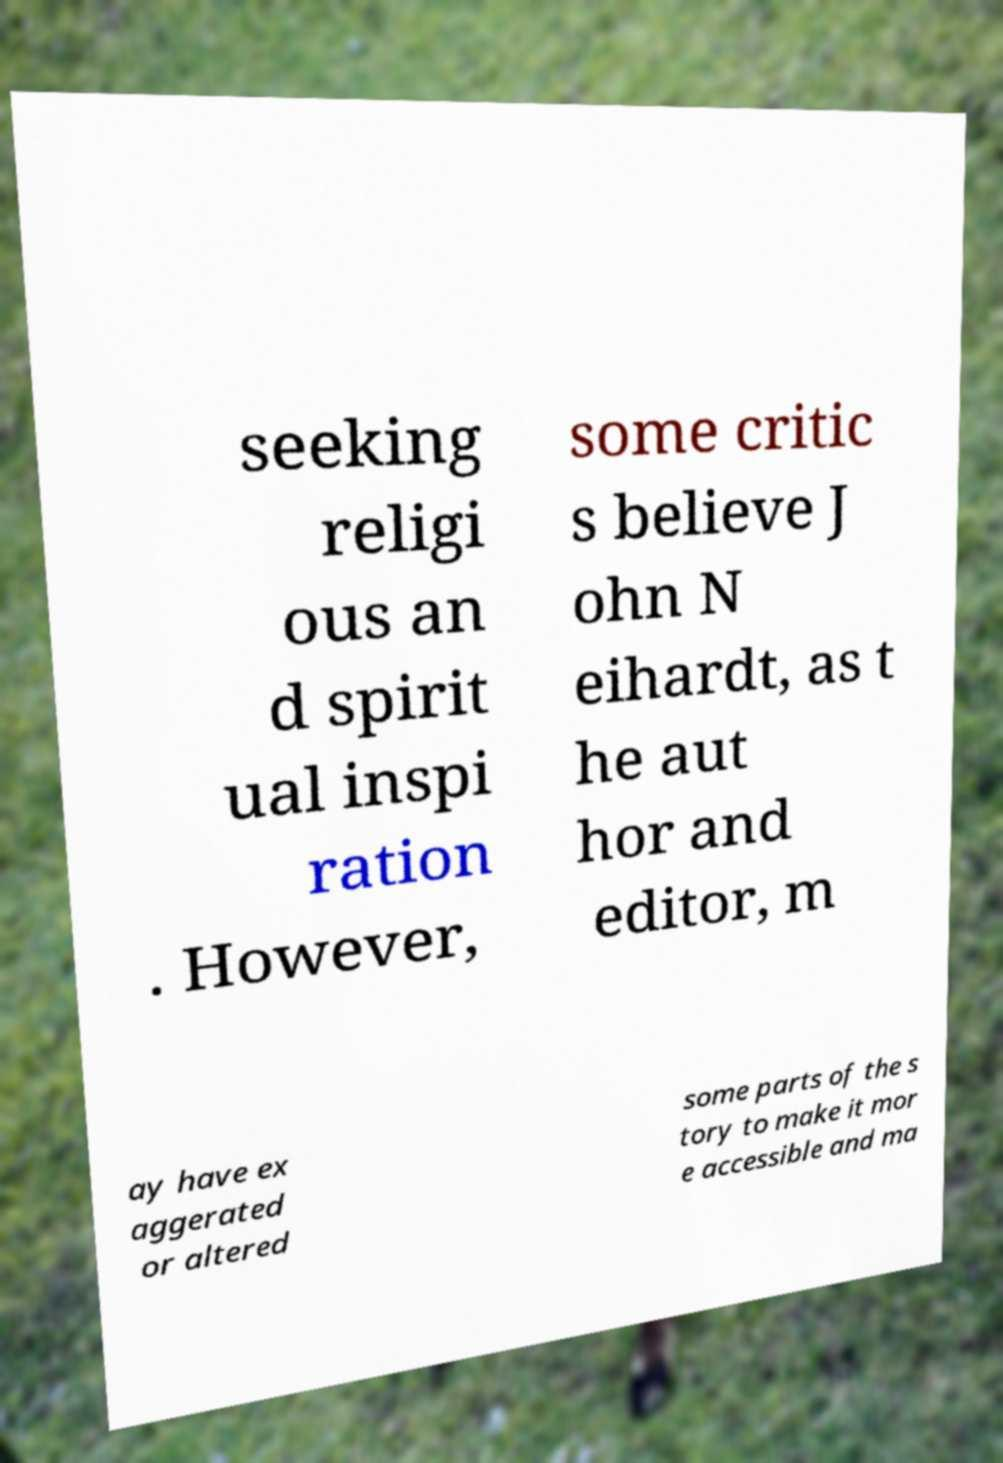What messages or text are displayed in this image? I need them in a readable, typed format. seeking religi ous an d spirit ual inspi ration . However, some critic s believe J ohn N eihardt, as t he aut hor and editor, m ay have ex aggerated or altered some parts of the s tory to make it mor e accessible and ma 